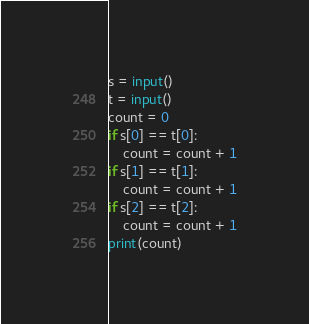<code> <loc_0><loc_0><loc_500><loc_500><_Python_>s = input()
t = input()
count = 0
if s[0] == t[0]:
    count = count + 1
if s[1] == t[1]:
    count = count + 1
if s[2] == t[2]:
    count = count + 1
print(count)</code> 